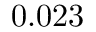<formula> <loc_0><loc_0><loc_500><loc_500>0 . 0 2 3</formula> 